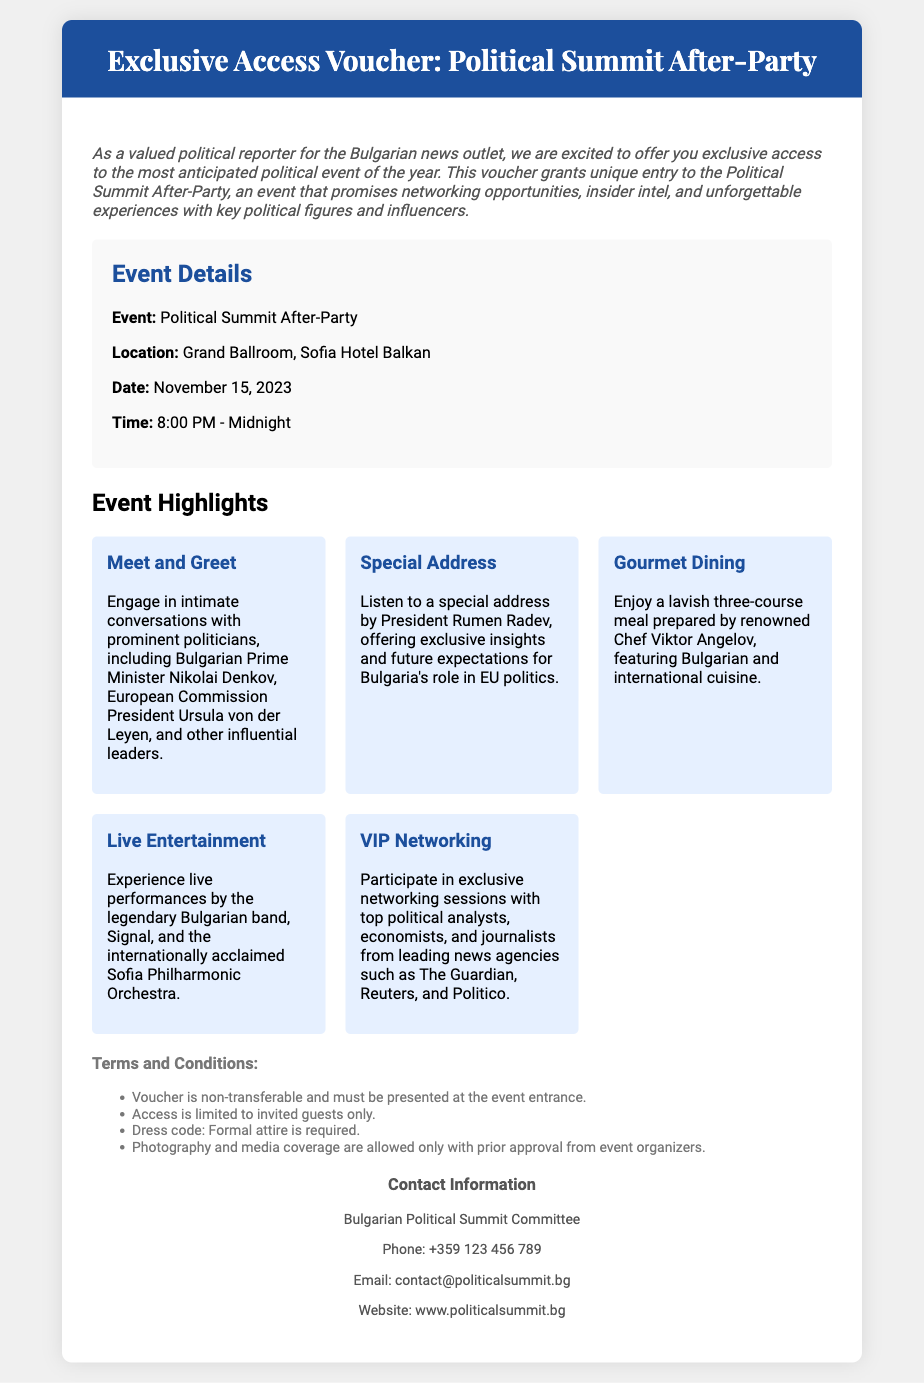What is the event? The document mentions the event as the "Political Summit After-Party."
Answer: Political Summit After-Party Where is the event located? The location of the event is highlighted in the document, stating it will be at the "Grand Ballroom, Sofia Hotel Balkan."
Answer: Grand Ballroom, Sofia Hotel Balkan What is the date of the event? The date of the event is mentioned in the document, which is "November 15, 2023."
Answer: November 15, 2023 Who will give a special address? The document specifies that "President Rumen Radev" will deliver a special address at the event.
Answer: President Rumen Radev What is required for entry? The document states that the voucher is "non-transferable and must be presented at the event entrance."
Answer: Voucher What is a highlight of the event involving food? The document describes "Gourmet Dining" as one of the event highlights, mentioning a "lavish three-course meal."
Answer: Gourmet Dining What type of attire is required? The dress code is outlined as "Formal attire is required" in the terms and conditions section.
Answer: Formal attire Which band will perform live? The document notes that the "legendary Bulgarian band, Signal" will perform at the event.
Answer: Signal What is the purpose of the voucher? The document states that it grants "exclusive access to the most anticipated political event of the year."
Answer: Exclusive access 